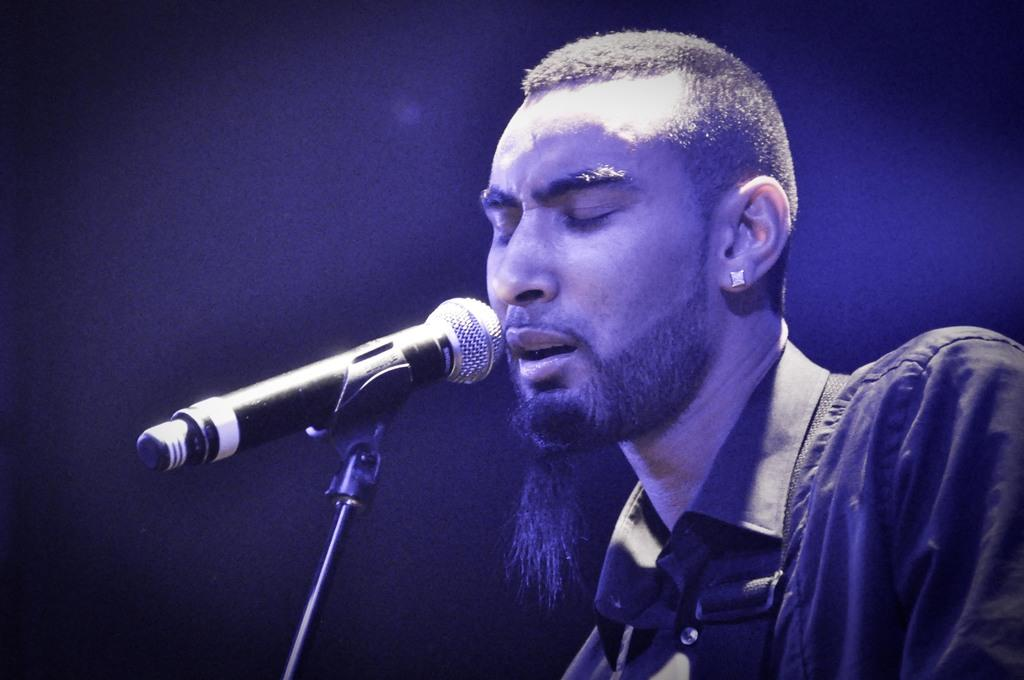Who or what is the main subject in the image? There is a person in the image. What is the person doing in the image? The person is in front of a microphone. What color is the background of the image? The background of the image is blue. What is the person wearing in the image? The person is wearing clothes. Can you see a card being held by the person in the image? There is no card visible in the image. Is there a bear present in the image? There is no bear present in the image. 